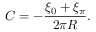Convert formula to latex. <formula><loc_0><loc_0><loc_500><loc_500>C = - { \frac { \xi _ { 0 } + \xi _ { \pi } } { 2 \pi R } } .</formula> 